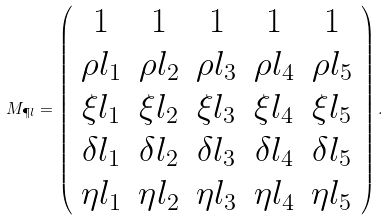<formula> <loc_0><loc_0><loc_500><loc_500>M _ { \P l } = \left ( \begin{array} { c c c c c } 1 & 1 & 1 & 1 & 1 \\ \rho l _ { 1 } & \rho l _ { 2 } & \rho l _ { 3 } & \rho l _ { 4 } & \rho l _ { 5 } \\ \xi l _ { 1 } & \xi l _ { 2 } & \xi l _ { 3 } & \xi l _ { 4 } & \xi l _ { 5 } \\ \delta l _ { 1 } & \delta l _ { 2 } & \delta l _ { 3 } & \delta l _ { 4 } & \delta l _ { 5 } \\ \eta l _ { 1 } & \eta l _ { 2 } & \eta l _ { 3 } & \eta l _ { 4 } & \eta l _ { 5 } \end{array} \right ) .</formula> 